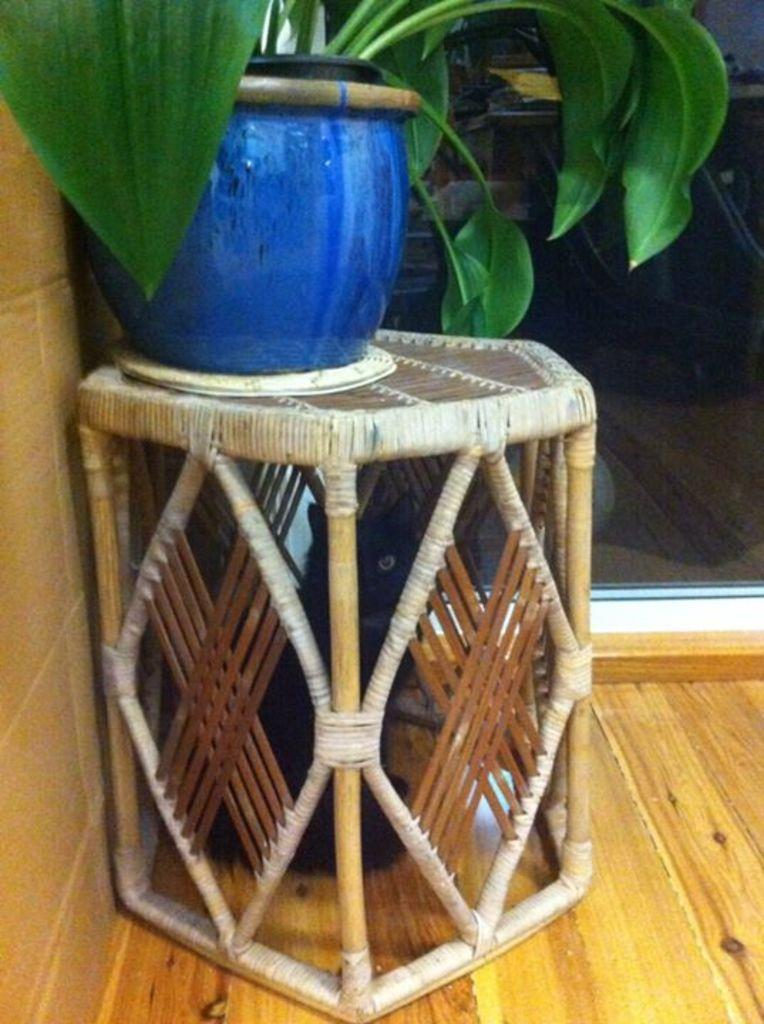What type of furniture is in the foreground of the image? There is a wooden table in the foreground of the image. What is placed on the wooden table? A houseplant is present on the wooden table. What can be seen in the background of the image? There is a glass in the background of the image. Where was the image taken? The image was taken in a room. What type of steam is coming from the arm of the person in the image? There is no person or steam present in the image; it features a wooden table with a houseplant and a glass in the background. 